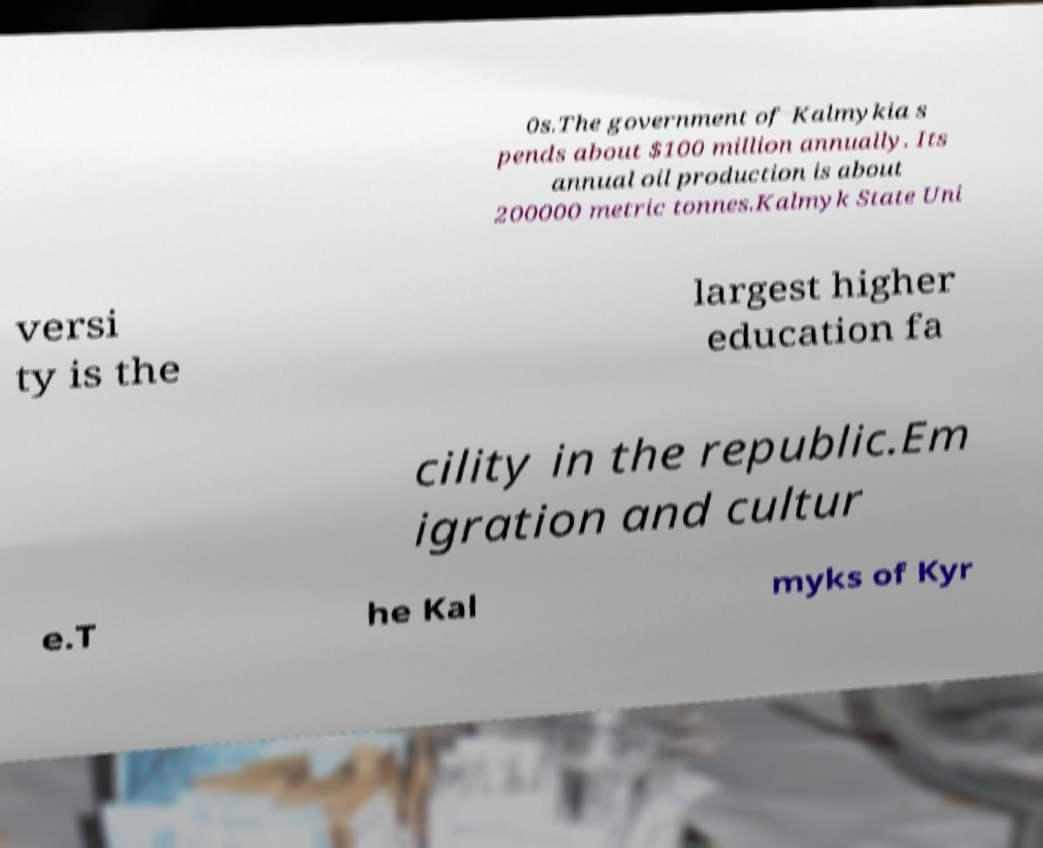I need the written content from this picture converted into text. Can you do that? 0s.The government of Kalmykia s pends about $100 million annually. Its annual oil production is about 200000 metric tonnes.Kalmyk State Uni versi ty is the largest higher education fa cility in the republic.Em igration and cultur e.T he Kal myks of Kyr 